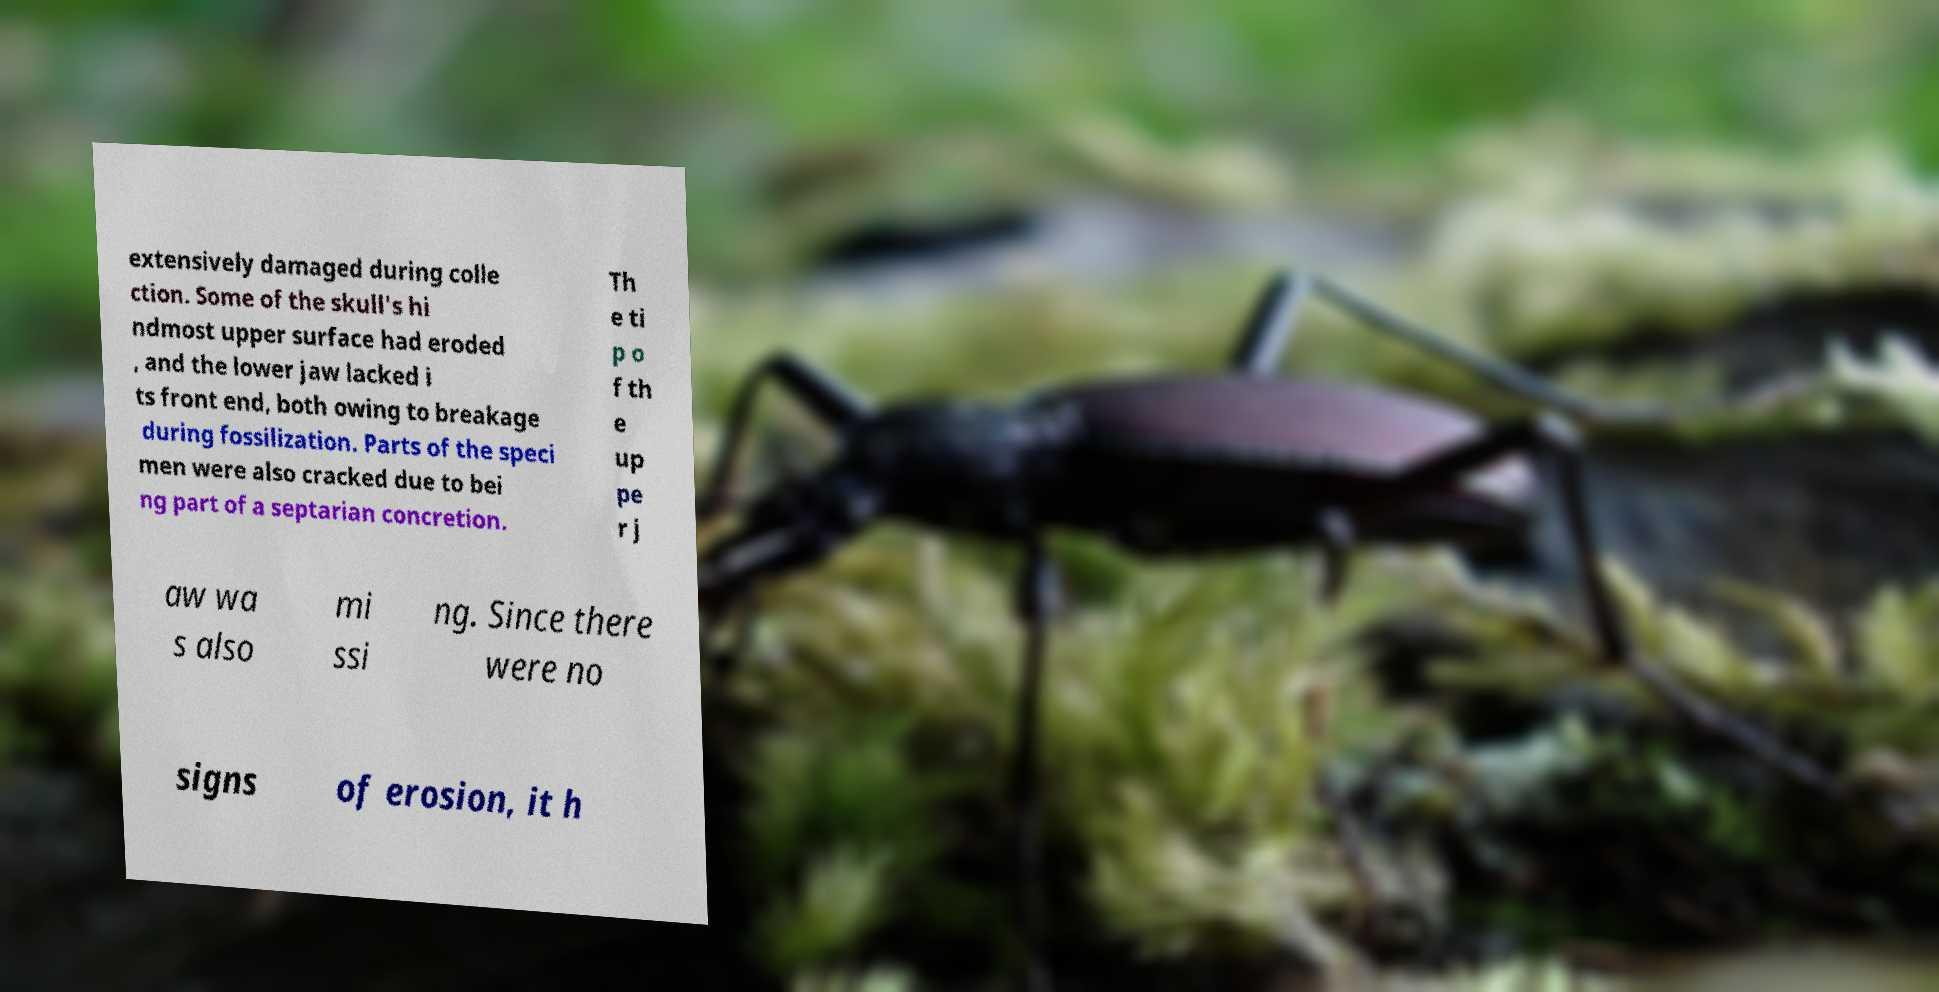Can you read and provide the text displayed in the image?This photo seems to have some interesting text. Can you extract and type it out for me? extensively damaged during colle ction. Some of the skull's hi ndmost upper surface had eroded , and the lower jaw lacked i ts front end, both owing to breakage during fossilization. Parts of the speci men were also cracked due to bei ng part of a septarian concretion. Th e ti p o f th e up pe r j aw wa s also mi ssi ng. Since there were no signs of erosion, it h 